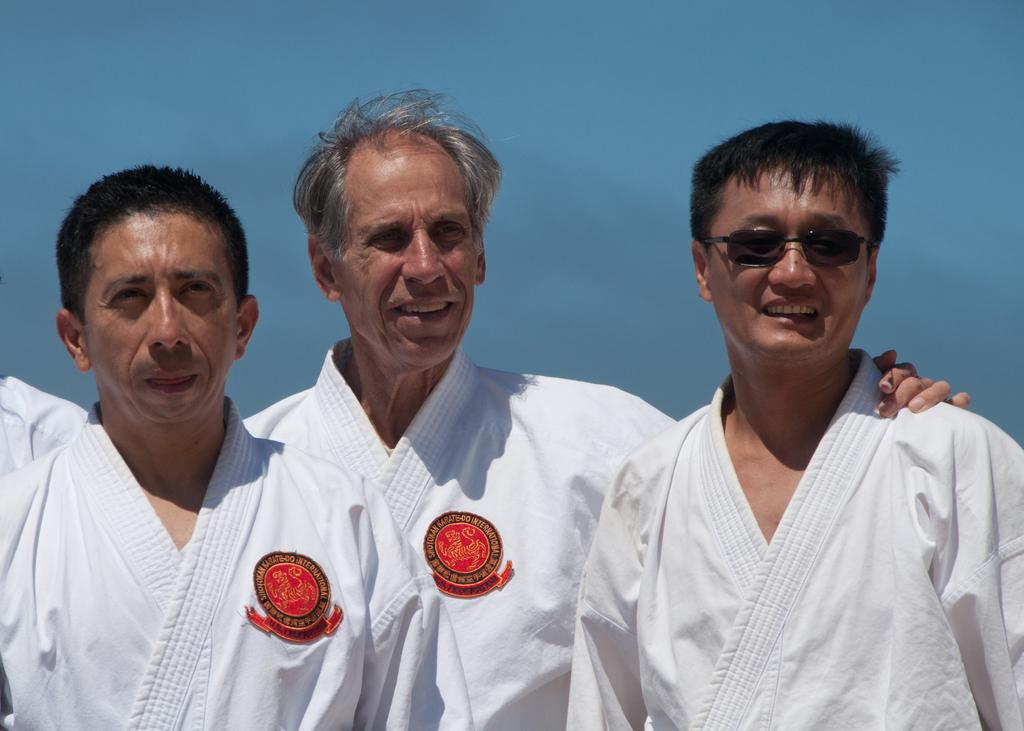How many people are in the image? There are three persons in the image. What are the persons wearing? The persons are wearing white-colored dresses. Can you describe any specific detail about one of the persons? One of the persons is wearing spectacles. What color is the background of the image? The background of the image is blue. How does the zephyr support the persons in the image? There is no mention of a zephyr in the image, so it cannot be said to support the persons. 